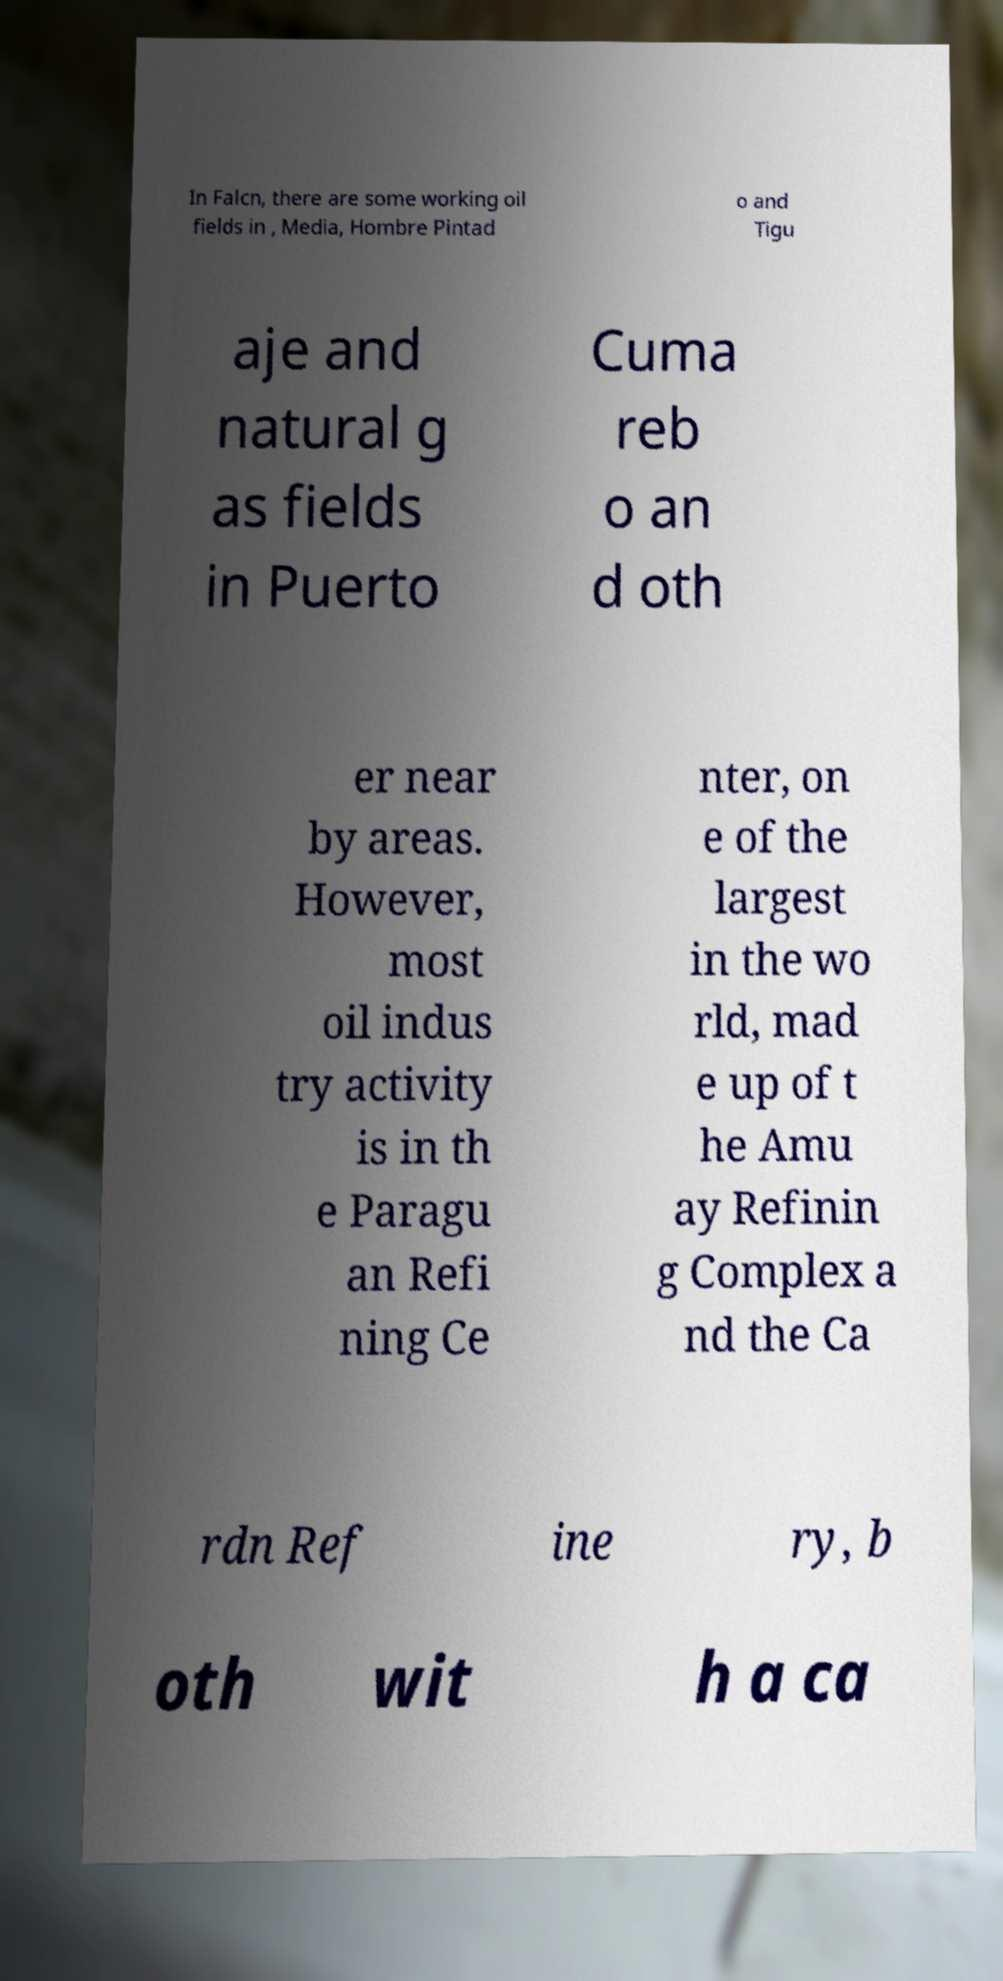Can you accurately transcribe the text from the provided image for me? In Falcn, there are some working oil fields in , Media, Hombre Pintad o and Tigu aje and natural g as fields in Puerto Cuma reb o an d oth er near by areas. However, most oil indus try activity is in th e Paragu an Refi ning Ce nter, on e of the largest in the wo rld, mad e up of t he Amu ay Refinin g Complex a nd the Ca rdn Ref ine ry, b oth wit h a ca 